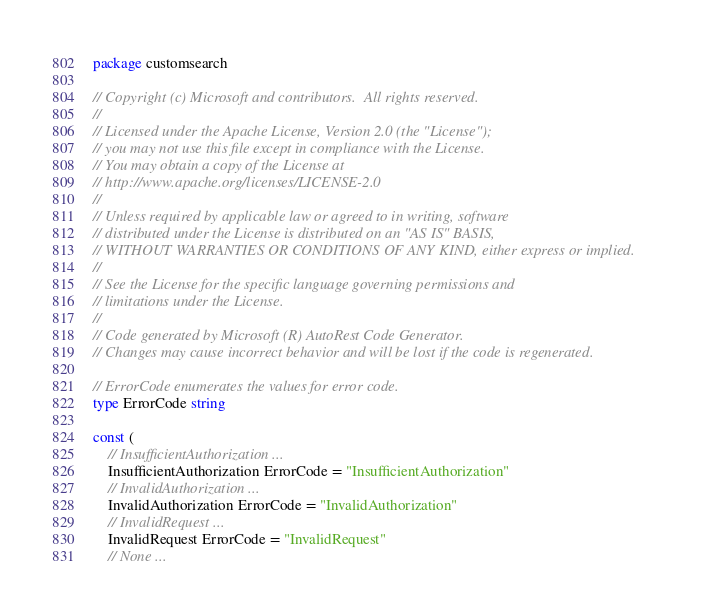<code> <loc_0><loc_0><loc_500><loc_500><_Go_>package customsearch

// Copyright (c) Microsoft and contributors.  All rights reserved.
//
// Licensed under the Apache License, Version 2.0 (the "License");
// you may not use this file except in compliance with the License.
// You may obtain a copy of the License at
// http://www.apache.org/licenses/LICENSE-2.0
//
// Unless required by applicable law or agreed to in writing, software
// distributed under the License is distributed on an "AS IS" BASIS,
// WITHOUT WARRANTIES OR CONDITIONS OF ANY KIND, either express or implied.
//
// See the License for the specific language governing permissions and
// limitations under the License.
//
// Code generated by Microsoft (R) AutoRest Code Generator.
// Changes may cause incorrect behavior and will be lost if the code is regenerated.

// ErrorCode enumerates the values for error code.
type ErrorCode string

const (
	// InsufficientAuthorization ...
	InsufficientAuthorization ErrorCode = "InsufficientAuthorization"
	// InvalidAuthorization ...
	InvalidAuthorization ErrorCode = "InvalidAuthorization"
	// InvalidRequest ...
	InvalidRequest ErrorCode = "InvalidRequest"
	// None ...</code> 